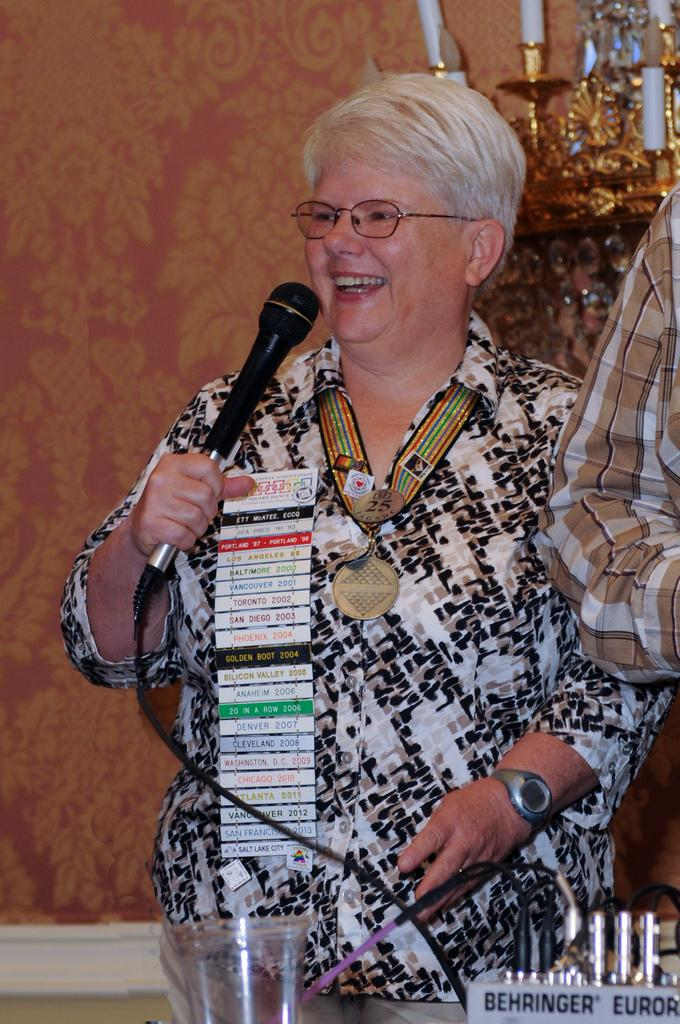Who is the main subject in the image? There is a woman in the image. Where is the woman positioned in the image? The woman is standing in the center. What is the woman holding in her hand? The woman is holding a microphone in her hand. What is the woman doing in the image? The woman is talking. How does the woman appear in the image? The woman has a bright smile on her face. How many pigs can be seen swimming in the background of the image? There are no pigs or any background visible in the image; it only features the woman. 